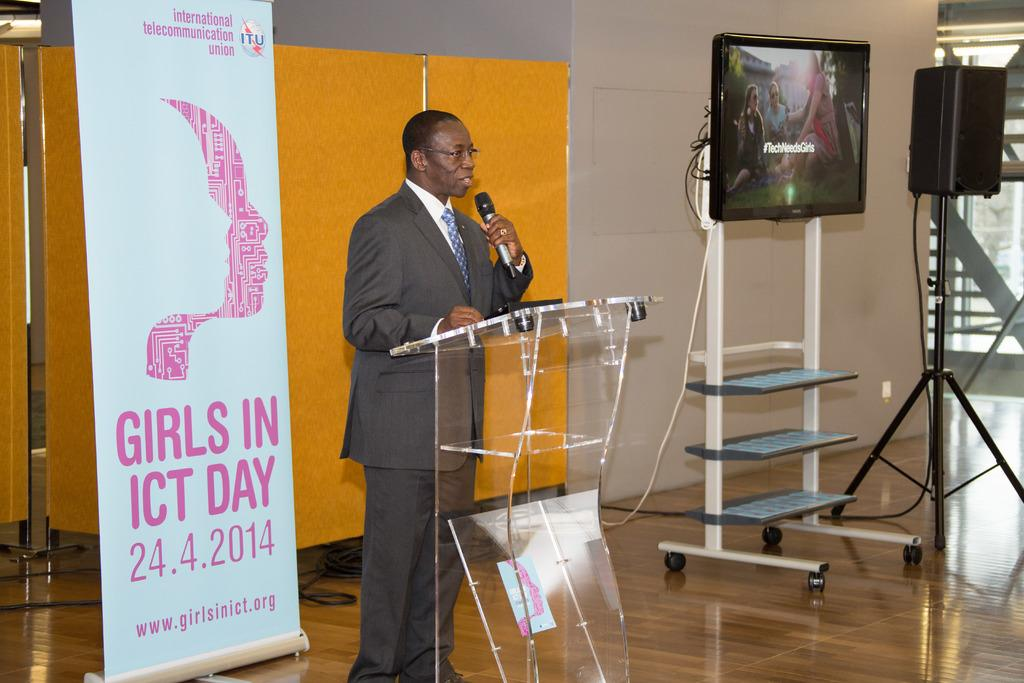Provide a one-sentence caption for the provided image. A man stands at a podium next to a banner advertising the girls in ICT day. 